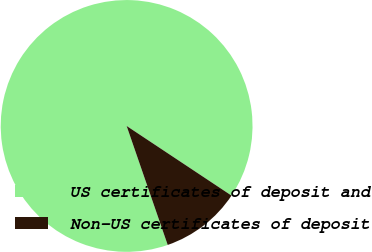Convert chart to OTSL. <chart><loc_0><loc_0><loc_500><loc_500><pie_chart><fcel>US certificates of deposit and<fcel>Non-US certificates of deposit<nl><fcel>89.62%<fcel>10.38%<nl></chart> 